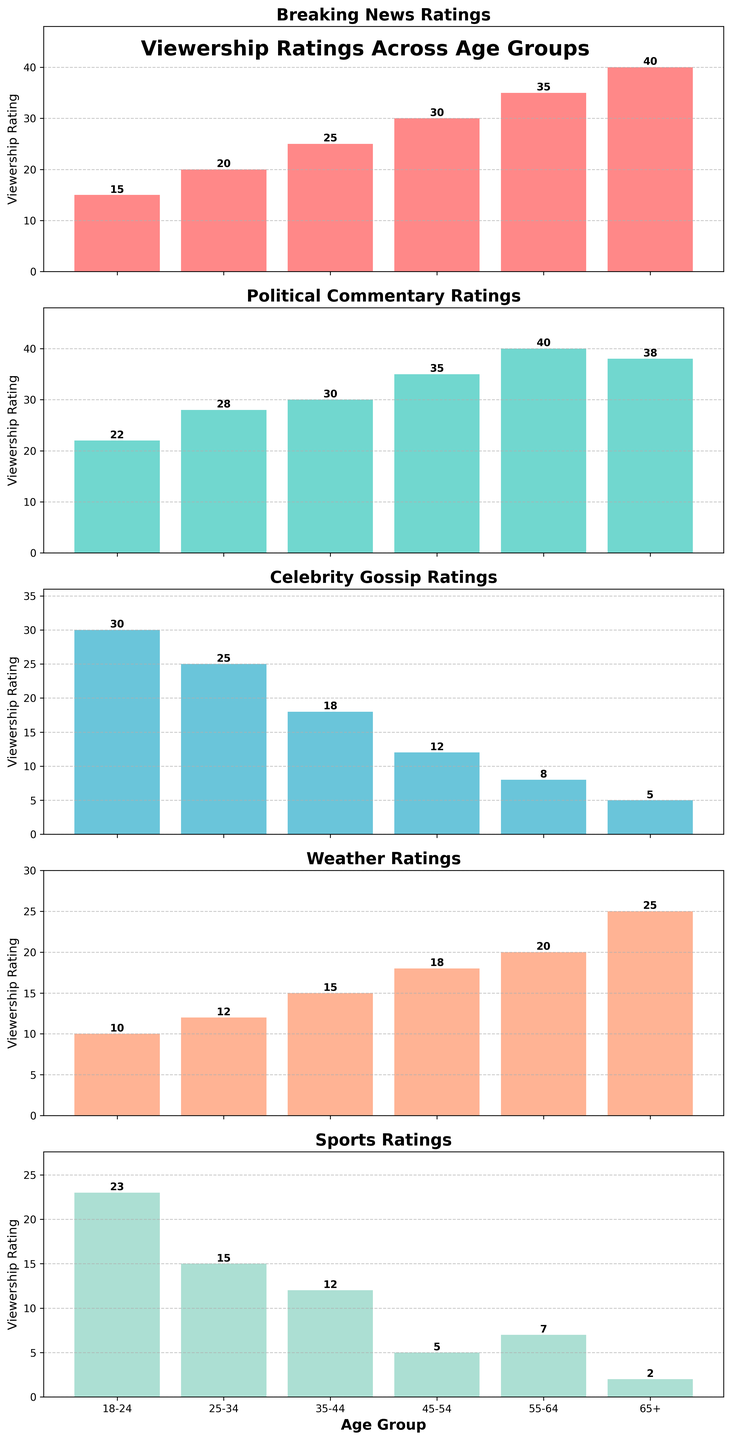What's the title of the figure? The title is written at the top of the figure. It reads "Viewership Ratings Across Age Groups."
Answer: Viewership Ratings Across Age Groups What is the viewership rating for "Celebrity Gossip" in the 18-24 age group? The bar for "Celebrity Gossip" in the 18-24 age group reaches up to the value 30, which is also marked at the end of the bar.
Answer: 30 Which news segment has the highest rating in the 45-54 age group? Looking at the 45-54 age group's bars across all subplots, the bar for "Political Commentary" is the highest, reaching up to 35.
Answer: Political Commentary What is the difference in viewership ratings for "Weather" between the 35-44 and 55-64 age groups? The "Weather" bar for 35-44 reaches 15, while for 55-64 it reaches 20. The difference is 20 - 15.
Answer: 5 How does the viewership rating for "Sports" in the 65+ age group compare to that in the 18-24 age group? The "Sports" rating for the 65+ age group is 2, whereas for the 18-24 age group, it is 23. So, 2 is much less than 23.
Answer: Much less What is the average viewership rating for "Breaking News" across all age groups? Summing up the ratings: 15 + 20 + 25 + 30 + 35 + 40 = 165. There are 6 age groups. Thus, the average rating is 165 / 6.
Answer: 27.5 Which age group shows the least interest in "Political Commentary"? The "Political Commentary" subplot reveals the lowest rating in the 18-24 age group, where the bar reaches 22.
Answer: 18-24 What is the total viewership rating for "Sports" across all age groups? Adding the "Sports" ratings for each age group: 23 + 15 + 12 + 5 + 7 + 2 = 64.
Answer: 64 Across which age groups do "Breaking News" ratings consistently increase? Observing the "Breaking News" subplot, the ratings rise consistently from 18-24 to 25-34 to 35-44 to 45-54 to 55-64 to 65+.
Answer: All age groups What is the highest viewership rating observed in the entire figure, and in which category and age group does it occur? The highest rating in the figure is 40, visible in "Breaking News" for the 65+ age group and "Political Commentary" for the 55-64 age group.
Answer: 40 in "Breaking News" (65+) and "Political Commentary" (55-64) 